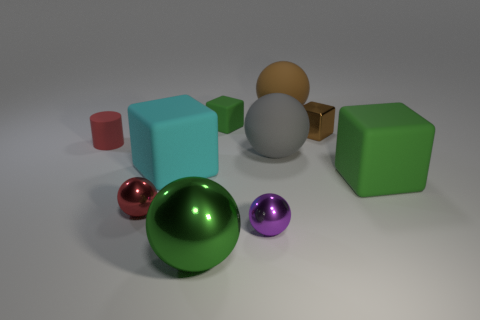There is a purple metallic ball; does it have the same size as the ball behind the small green rubber object? The purple metallic ball appears to be slightly smaller than the ball behind the small green rubber object when looking at their relative sizes in the image. The perspective may affect perception of size, but the purple ball seems to have a slightly smaller diameter. 